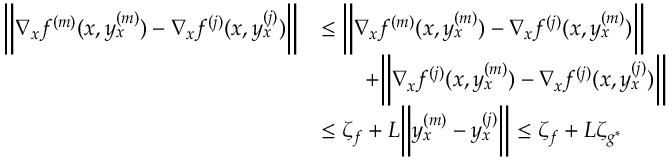Convert formula to latex. <formula><loc_0><loc_0><loc_500><loc_500>\begin{array} { r l } { \left \| \nabla _ { x } f ^ { ( m ) } ( x , y _ { x } ^ { ( m ) } ) - \nabla _ { x } f ^ { ( j ) } ( x , y _ { x } ^ { ( j ) } ) \right \| } & { \leq \left \| \nabla _ { x } f ^ { ( m ) } ( x , y _ { x } ^ { ( m ) } ) - \nabla _ { x } f ^ { ( j ) } ( x , y _ { x } ^ { ( m ) } ) \right \| } \\ & { \quad + \left \| \nabla _ { x } f ^ { ( j ) } ( x , y _ { x } ^ { ( m ) } ) - \nabla _ { x } f ^ { ( j ) } ( x , y _ { x } ^ { ( j ) } ) \right \| } \\ & { \leq \zeta _ { f } + L \left \| y _ { x } ^ { ( m ) } - y _ { x } ^ { ( j ) } \right \| \leq \zeta _ { f } + L \zeta _ { g ^ { \ast } } } \end{array}</formula> 